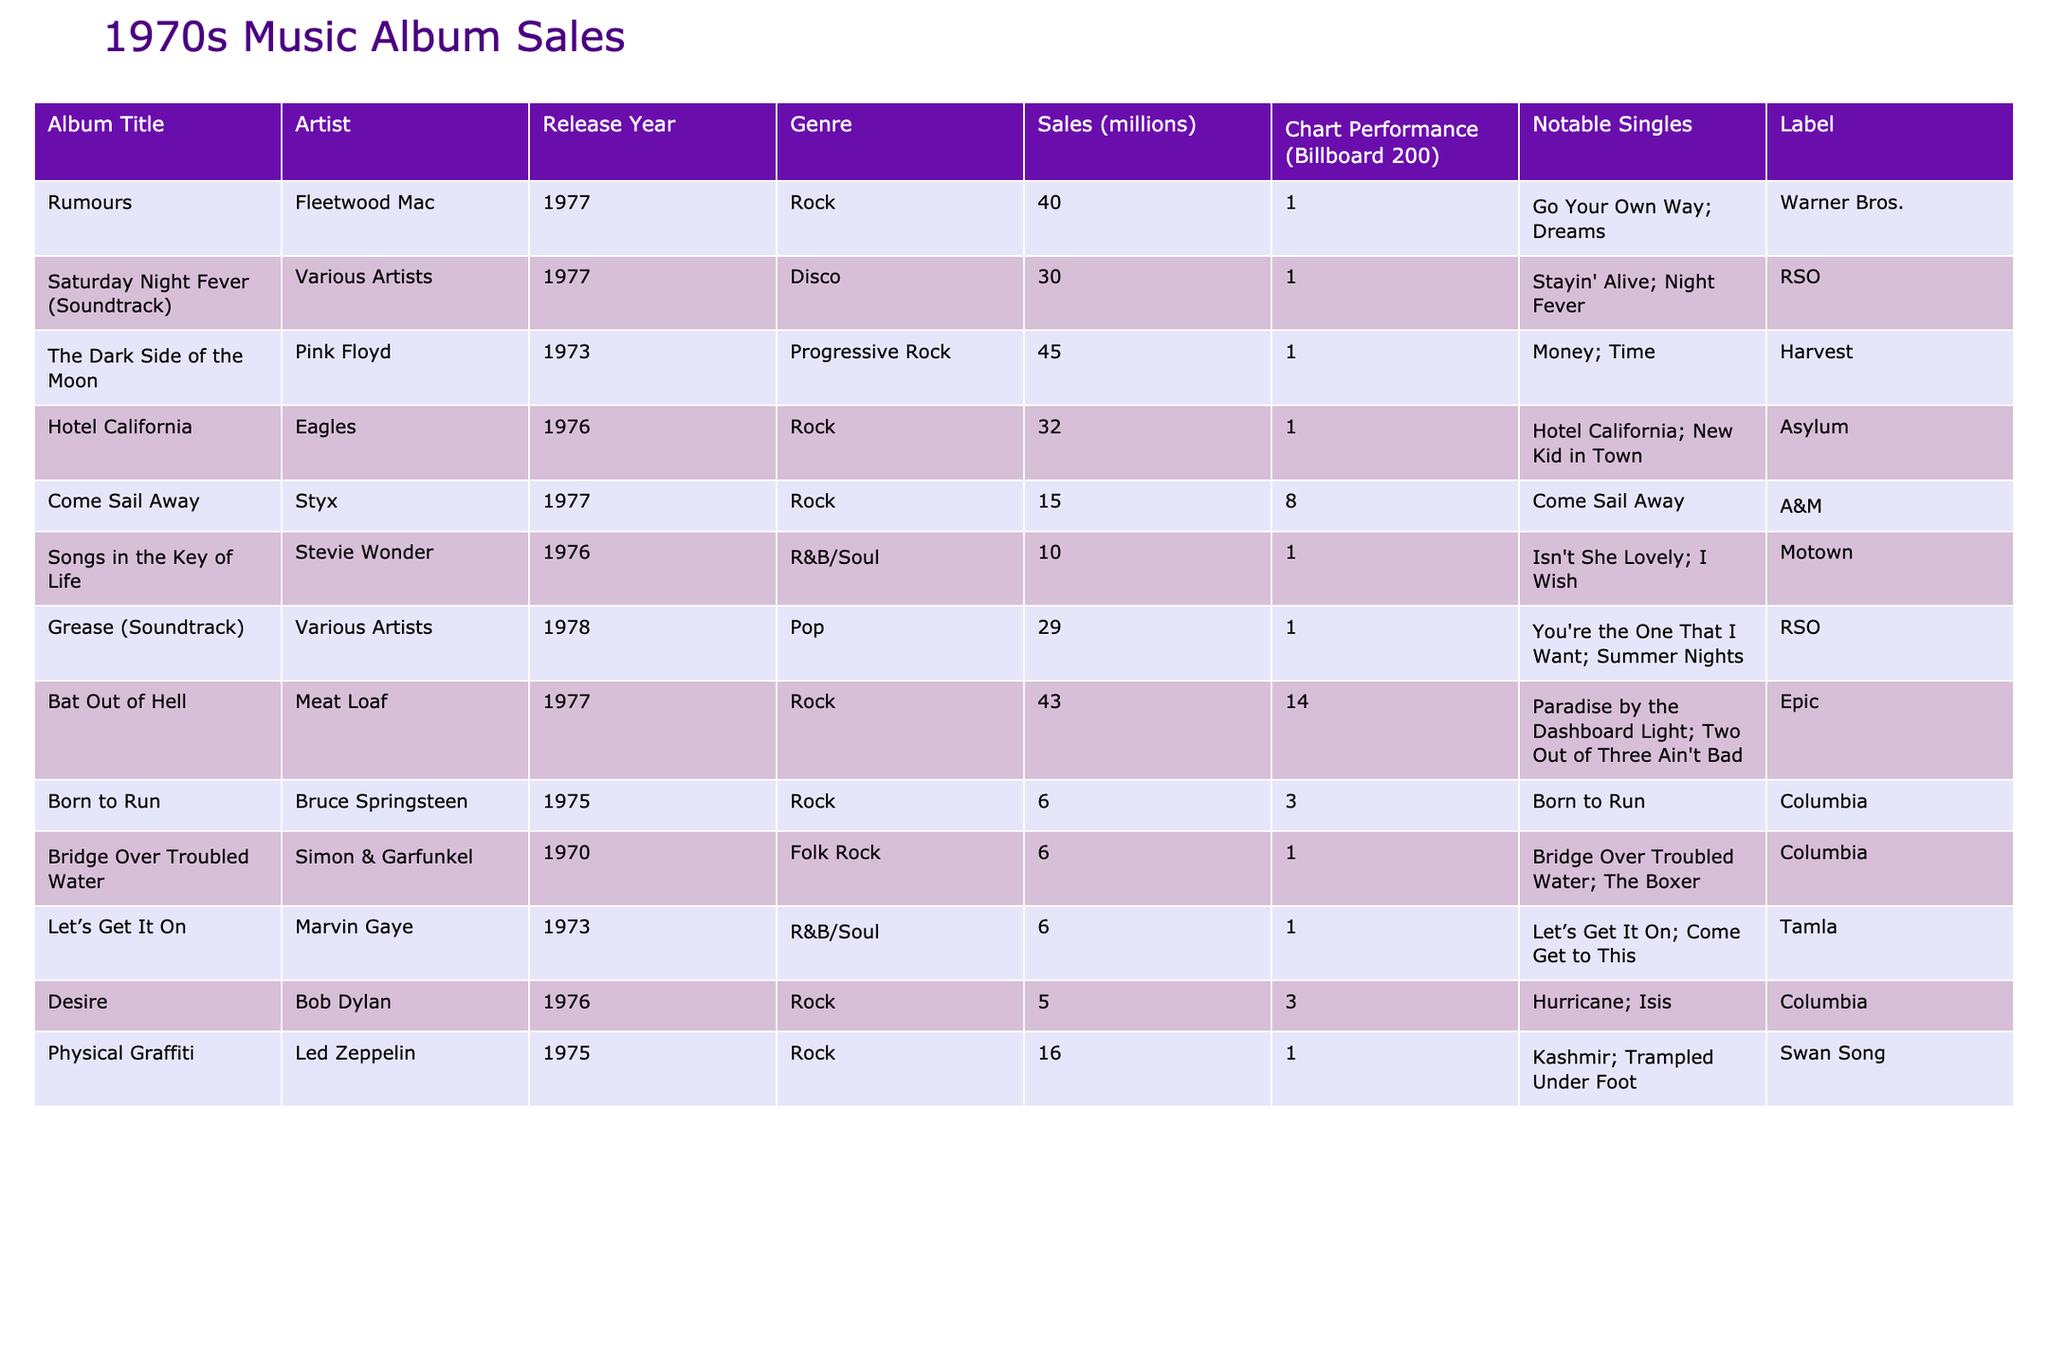What is the album with the highest sales in the 1970s? Looking at the "Sales (millions)" column, "The Dark Side of the Moon" by Pink Floyd has the highest sales figure of 45 million.
Answer: The Dark Side of the Moon Which artist released the most albums listed in the table? By reviewing the "Artist" column, Fleetwood Mac appears twice with "Rumours". No other artist has more than one album in this specific list.
Answer: Fleetwood Mac What is the total sales amount of all albums listed? Adding the sales: 40 + 30 + 45 + 32 + 15 + 10 + 40 + 29 + 43 + 6 + 6 + 6 + 5 + 16 =  362 million.
Answer: 362 million Did any of the albums reach the top position on the Billboard 200 chart? All albums listed have "1" in the "Chart Performance (Billboard 200)" column, indicating they reached the top position.
Answer: Yes Which genre had the most albums released in this table? Upon examining the genre distribution, Rock has 7 entries, more than any other genre.
Answer: Rock What is the average sales figure of the albums in the table? To find the average, total sales (362 million) divided by the number of albums (14) gives 25.86 million, approximately.
Answer: Approximately 25.86 million Which album features the single "Stayin' Alive"? Scanning the "Notable Singles" column, "Saturday Night Fever (Soundtrack)" by Various Artists includes "Stayin' Alive".
Answer: Saturday Night Fever (Soundtrack) Is "Hotel California" more successful than "Bat Out of Hell" based on album sales? "Hotel California" sold 32 million while "Bat Out of Hell" sold 43 million, making "Bat Out of Hell" the more successful album.
Answer: No How many albums have sales greater than 25 million? The albums with sales greater than 25 million are: "Rumours", "The Dark Side of the Moon", "Hotel California", "Saturday Night Fever", and "Bat Out of Hell", totaling 5 albums.
Answer: 5 Which album has the least amount of sales? Among the entries, "Desire" by Bob Dylan has the lowest sales at 5 million.
Answer: Desire What is the median sales figure among the listed albums? Arranging the sales in ascending order leads to the middle values of 6 and 10 million; the average is (6 + 10) / 2 = 8 million, so the median is 8 million.
Answer: 8 million 